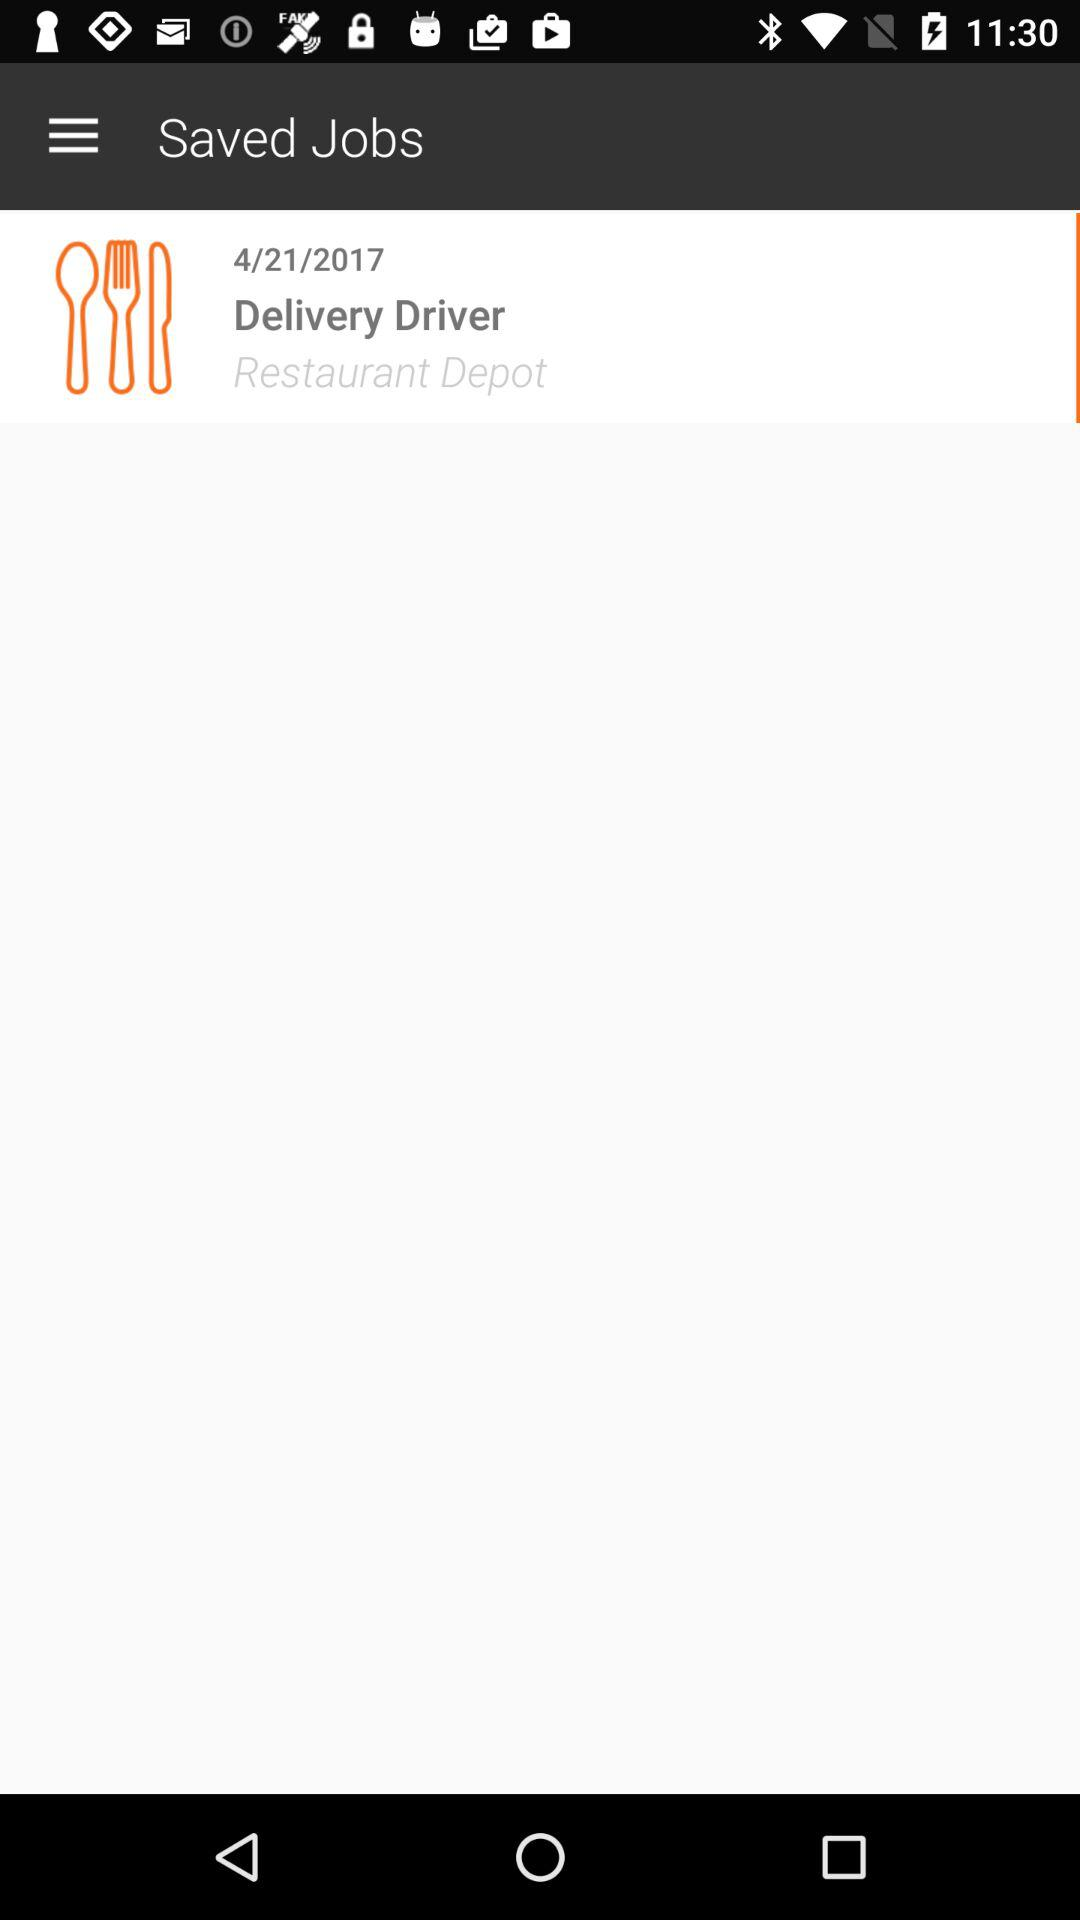On what date was the delivery driver job posted? The delivery driver job was posted on April 21, 2017. 